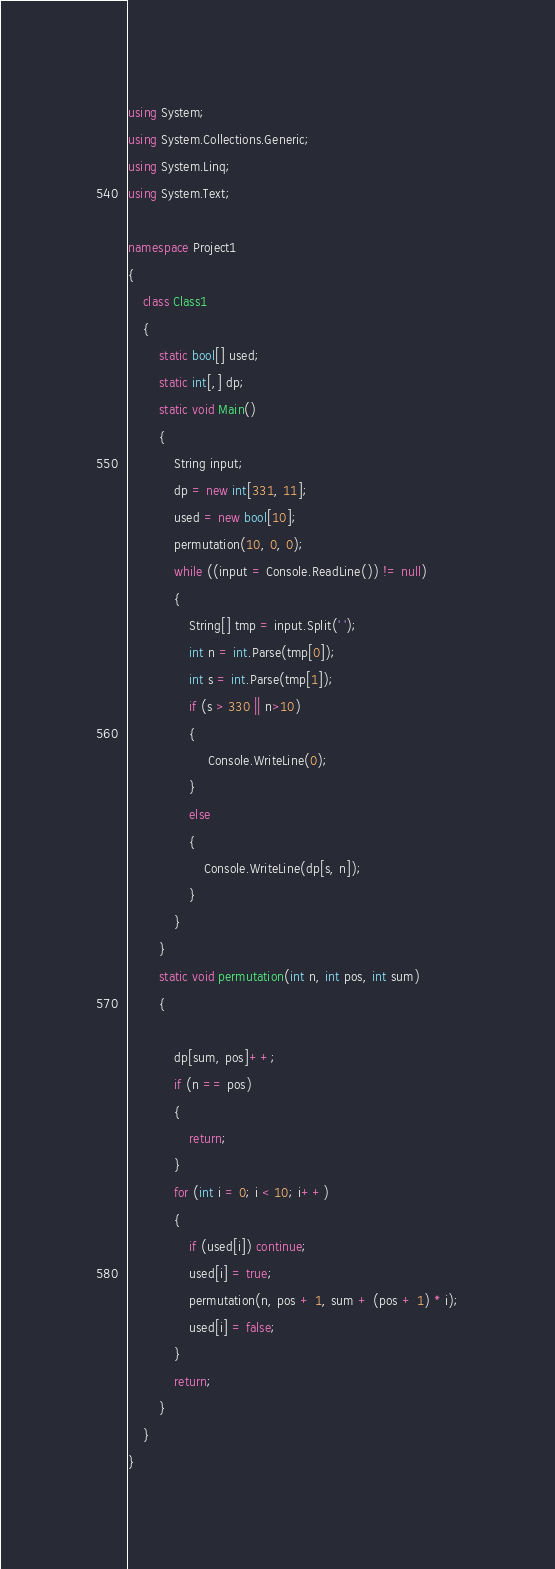Convert code to text. <code><loc_0><loc_0><loc_500><loc_500><_C#_>using System;
using System.Collections.Generic;
using System.Linq;
using System.Text;

namespace Project1
{
    class Class1
    {
        static bool[] used;
        static int[,] dp;
        static void Main()
        {
            String input;
            dp = new int[331, 11];
            used = new bool[10];
            permutation(10, 0, 0);
            while ((input = Console.ReadLine()) != null)
            {
                String[] tmp = input.Split(' ');
                int n = int.Parse(tmp[0]);
                int s = int.Parse(tmp[1]);
                if (s > 330 || n>10)
                {
                     Console.WriteLine(0);
                }
                else
                {
                    Console.WriteLine(dp[s, n]);
                }
            }
        }
        static void permutation(int n, int pos, int sum)
        {

            dp[sum, pos]++;
            if (n == pos)
            {
                return;
            }
            for (int i = 0; i < 10; i++)
            {
                if (used[i]) continue;
                used[i] = true;
                permutation(n, pos + 1, sum + (pos + 1) * i);
                used[i] = false;
            }
            return;
        }
    }
}</code> 